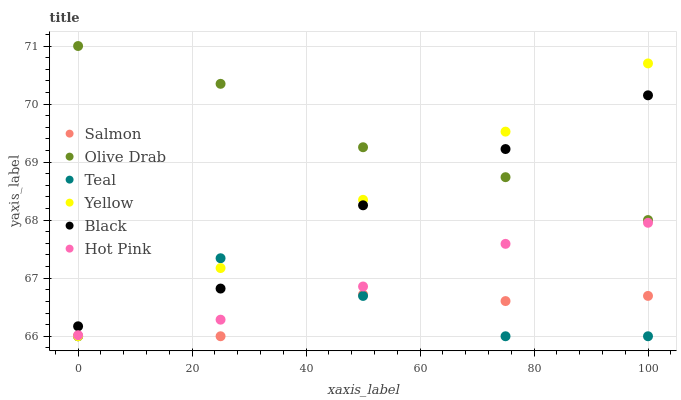Does Salmon have the minimum area under the curve?
Answer yes or no. Yes. Does Olive Drab have the maximum area under the curve?
Answer yes or no. Yes. Does Yellow have the minimum area under the curve?
Answer yes or no. No. Does Yellow have the maximum area under the curve?
Answer yes or no. No. Is Yellow the smoothest?
Answer yes or no. Yes. Is Teal the roughest?
Answer yes or no. Yes. Is Salmon the smoothest?
Answer yes or no. No. Is Salmon the roughest?
Answer yes or no. No. Does Salmon have the lowest value?
Answer yes or no. Yes. Does Black have the lowest value?
Answer yes or no. No. Does Olive Drab have the highest value?
Answer yes or no. Yes. Does Yellow have the highest value?
Answer yes or no. No. Is Salmon less than Hot Pink?
Answer yes or no. Yes. Is Black greater than Salmon?
Answer yes or no. Yes. Does Yellow intersect Hot Pink?
Answer yes or no. Yes. Is Yellow less than Hot Pink?
Answer yes or no. No. Is Yellow greater than Hot Pink?
Answer yes or no. No. Does Salmon intersect Hot Pink?
Answer yes or no. No. 